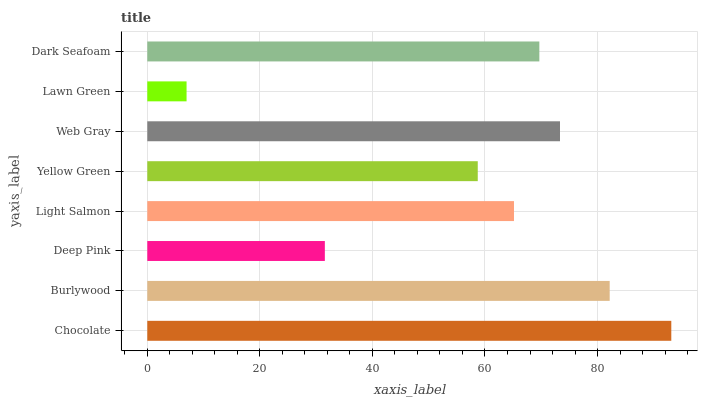Is Lawn Green the minimum?
Answer yes or no. Yes. Is Chocolate the maximum?
Answer yes or no. Yes. Is Burlywood the minimum?
Answer yes or no. No. Is Burlywood the maximum?
Answer yes or no. No. Is Chocolate greater than Burlywood?
Answer yes or no. Yes. Is Burlywood less than Chocolate?
Answer yes or no. Yes. Is Burlywood greater than Chocolate?
Answer yes or no. No. Is Chocolate less than Burlywood?
Answer yes or no. No. Is Dark Seafoam the high median?
Answer yes or no. Yes. Is Light Salmon the low median?
Answer yes or no. Yes. Is Deep Pink the high median?
Answer yes or no. No. Is Lawn Green the low median?
Answer yes or no. No. 